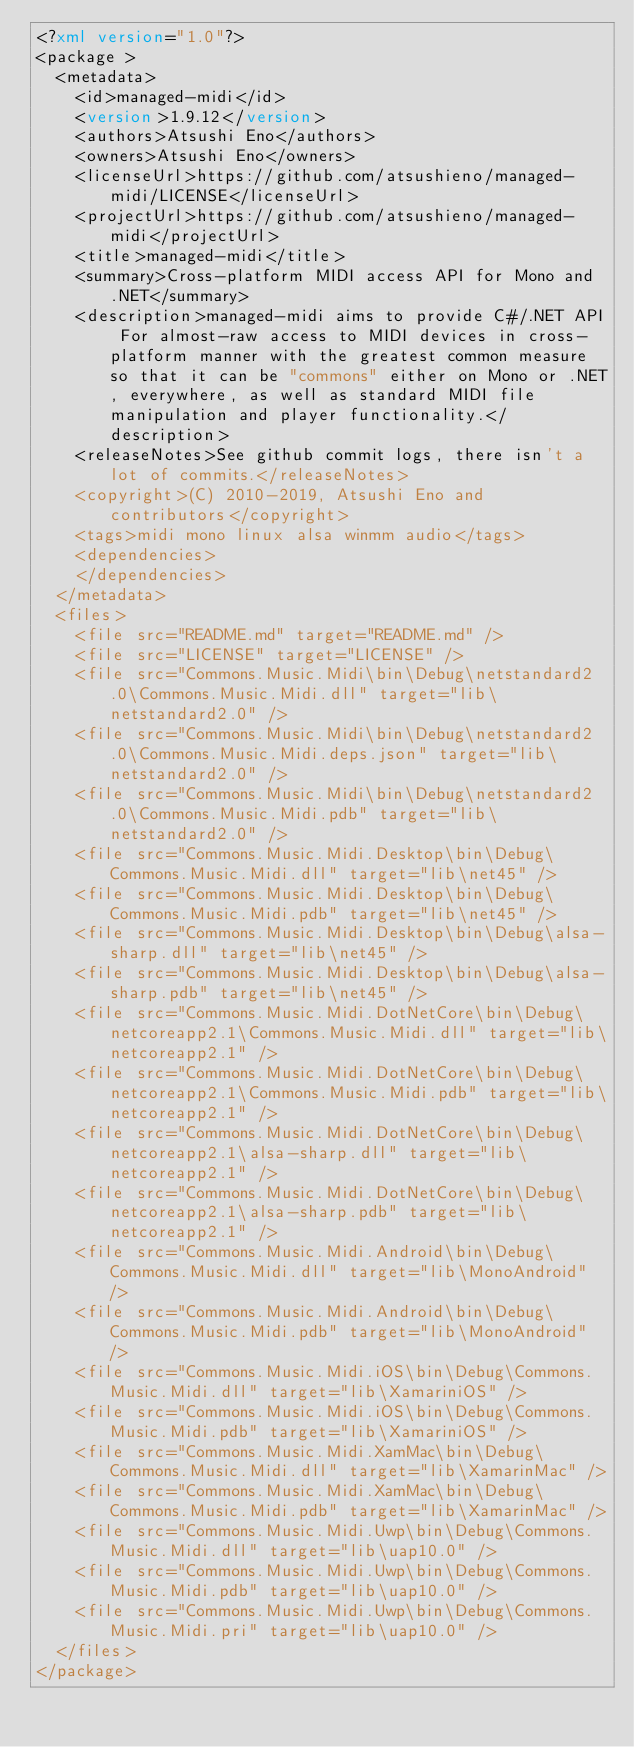<code> <loc_0><loc_0><loc_500><loc_500><_XML_><?xml version="1.0"?>
<package >
  <metadata>
    <id>managed-midi</id>
    <version>1.9.12</version>
    <authors>Atsushi Eno</authors>
    <owners>Atsushi Eno</owners>
    <licenseUrl>https://github.com/atsushieno/managed-midi/LICENSE</licenseUrl>
    <projectUrl>https://github.com/atsushieno/managed-midi</projectUrl>
    <title>managed-midi</title>
    <summary>Cross-platform MIDI access API for Mono and .NET</summary>
    <description>managed-midi aims to provide C#/.NET API For almost-raw access to MIDI devices in cross-platform manner with the greatest common measure so that it can be "commons" either on Mono or .NET, everywhere, as well as standard MIDI file manipulation and player functionality.</description>
    <releaseNotes>See github commit logs, there isn't a lot of commits.</releaseNotes>
    <copyright>(C) 2010-2019, Atsushi Eno and contributors</copyright> 
    <tags>midi mono linux alsa winmm audio</tags>
    <dependencies>
    </dependencies>
  </metadata>
  <files>
    <file src="README.md" target="README.md" />
    <file src="LICENSE" target="LICENSE" />
    <file src="Commons.Music.Midi\bin\Debug\netstandard2.0\Commons.Music.Midi.dll" target="lib\netstandard2.0" />
    <file src="Commons.Music.Midi\bin\Debug\netstandard2.0\Commons.Music.Midi.deps.json" target="lib\netstandard2.0" />
    <file src="Commons.Music.Midi\bin\Debug\netstandard2.0\Commons.Music.Midi.pdb" target="lib\netstandard2.0" />
    <file src="Commons.Music.Midi.Desktop\bin\Debug\Commons.Music.Midi.dll" target="lib\net45" />
    <file src="Commons.Music.Midi.Desktop\bin\Debug\Commons.Music.Midi.pdb" target="lib\net45" />
    <file src="Commons.Music.Midi.Desktop\bin\Debug\alsa-sharp.dll" target="lib\net45" />
    <file src="Commons.Music.Midi.Desktop\bin\Debug\alsa-sharp.pdb" target="lib\net45" />
    <file src="Commons.Music.Midi.DotNetCore\bin\Debug\netcoreapp2.1\Commons.Music.Midi.dll" target="lib\netcoreapp2.1" />
    <file src="Commons.Music.Midi.DotNetCore\bin\Debug\netcoreapp2.1\Commons.Music.Midi.pdb" target="lib\netcoreapp2.1" />
    <file src="Commons.Music.Midi.DotNetCore\bin\Debug\netcoreapp2.1\alsa-sharp.dll" target="lib\netcoreapp2.1" />
    <file src="Commons.Music.Midi.DotNetCore\bin\Debug\netcoreapp2.1\alsa-sharp.pdb" target="lib\netcoreapp2.1" />
    <file src="Commons.Music.Midi.Android\bin\Debug\Commons.Music.Midi.dll" target="lib\MonoAndroid" />
    <file src="Commons.Music.Midi.Android\bin\Debug\Commons.Music.Midi.pdb" target="lib\MonoAndroid" />
    <file src="Commons.Music.Midi.iOS\bin\Debug\Commons.Music.Midi.dll" target="lib\XamariniOS" />
    <file src="Commons.Music.Midi.iOS\bin\Debug\Commons.Music.Midi.pdb" target="lib\XamariniOS" />
    <file src="Commons.Music.Midi.XamMac\bin\Debug\Commons.Music.Midi.dll" target="lib\XamarinMac" />
    <file src="Commons.Music.Midi.XamMac\bin\Debug\Commons.Music.Midi.pdb" target="lib\XamarinMac" />
    <file src="Commons.Music.Midi.Uwp\bin\Debug\Commons.Music.Midi.dll" target="lib\uap10.0" />
    <file src="Commons.Music.Midi.Uwp\bin\Debug\Commons.Music.Midi.pdb" target="lib\uap10.0" />
    <file src="Commons.Music.Midi.Uwp\bin\Debug\Commons.Music.Midi.pri" target="lib\uap10.0" />
  </files>
</package>

</code> 